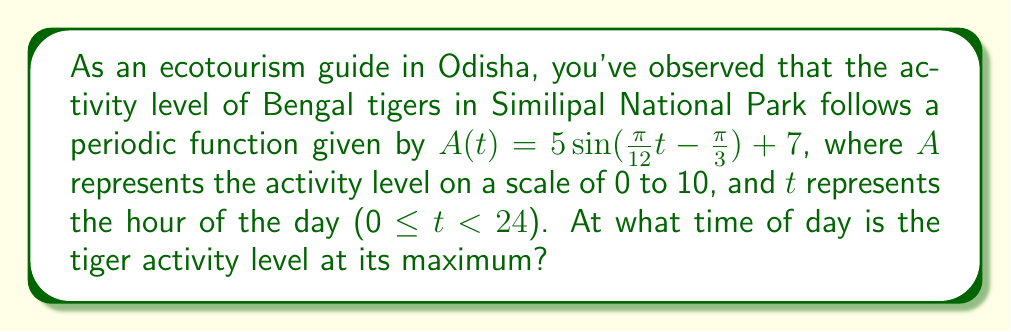Could you help me with this problem? To find the maximum activity level, we need to determine when the sine function reaches its peak value:

1) The general form of a sine function is $f(t) = a\sin(bt - c) + d$, where:
   $a$ is the amplitude
   $b$ is the angular frequency
   $c$ is the phase shift
   $d$ is the vertical shift

2) In our function $A(t) = 5\sin(\frac{\pi}{12}t - \frac{\pi}{3}) + 7$:
   $a = 5$
   $b = \frac{\pi}{12}$
   $c = \frac{\pi}{3}$
   $d = 7$

3) The sine function reaches its maximum when $bt - c = \frac{\pi}{2}$ (or 90°)

4) Solving for $t$:
   $\frac{\pi}{12}t - \frac{\pi}{3} = \frac{\pi}{2}$
   $\frac{\pi}{12}t = \frac{\pi}{2} + \frac{\pi}{3} = \frac{5\pi}{6}$
   $t = \frac{5\pi}{6} \cdot \frac{12}{\pi} = 10$

5) Since $t$ represents hours and we started at 0, this corresponds to 10:00 AM.

Therefore, the tiger activity level reaches its maximum at 10:00 AM.
Answer: 10:00 AM 